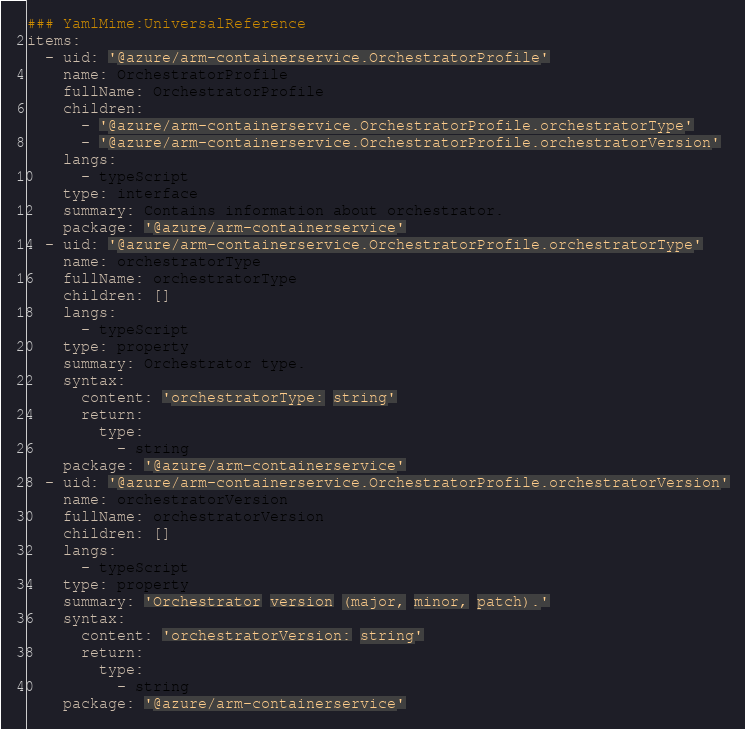Convert code to text. <code><loc_0><loc_0><loc_500><loc_500><_YAML_>### YamlMime:UniversalReference
items:
  - uid: '@azure/arm-containerservice.OrchestratorProfile'
    name: OrchestratorProfile
    fullName: OrchestratorProfile
    children:
      - '@azure/arm-containerservice.OrchestratorProfile.orchestratorType'
      - '@azure/arm-containerservice.OrchestratorProfile.orchestratorVersion'
    langs:
      - typeScript
    type: interface
    summary: Contains information about orchestrator.
    package: '@azure/arm-containerservice'
  - uid: '@azure/arm-containerservice.OrchestratorProfile.orchestratorType'
    name: orchestratorType
    fullName: orchestratorType
    children: []
    langs:
      - typeScript
    type: property
    summary: Orchestrator type.
    syntax:
      content: 'orchestratorType: string'
      return:
        type:
          - string
    package: '@azure/arm-containerservice'
  - uid: '@azure/arm-containerservice.OrchestratorProfile.orchestratorVersion'
    name: orchestratorVersion
    fullName: orchestratorVersion
    children: []
    langs:
      - typeScript
    type: property
    summary: 'Orchestrator version (major, minor, patch).'
    syntax:
      content: 'orchestratorVersion: string'
      return:
        type:
          - string
    package: '@azure/arm-containerservice'
</code> 